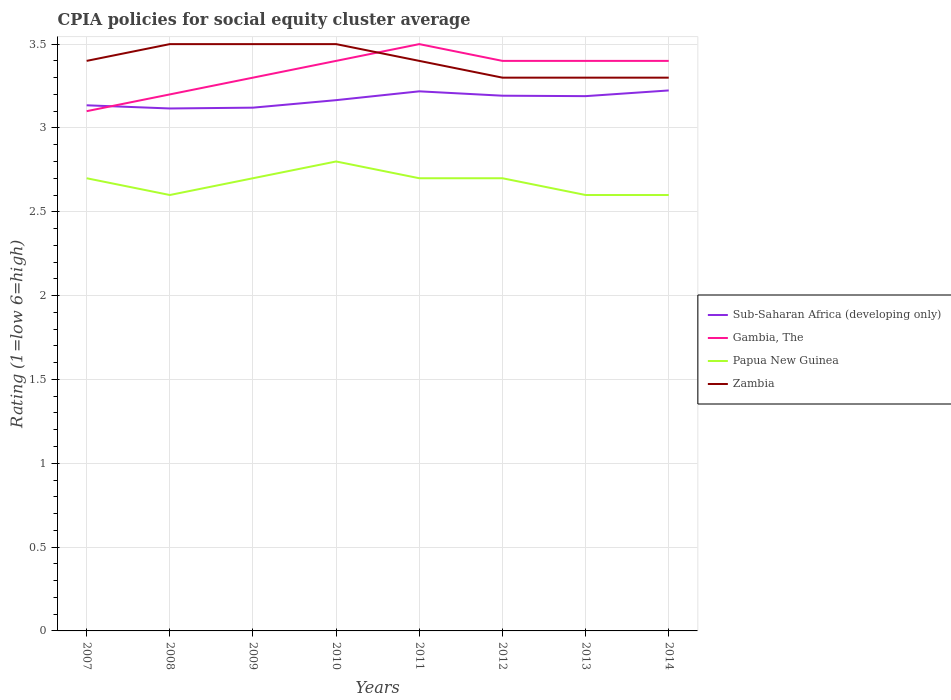Is the number of lines equal to the number of legend labels?
Make the answer very short. Yes. In which year was the CPIA rating in Zambia maximum?
Keep it short and to the point. 2012. What is the total CPIA rating in Gambia, The in the graph?
Make the answer very short. -0.2. What is the difference between the highest and the second highest CPIA rating in Sub-Saharan Africa (developing only)?
Offer a terse response. 0.11. What is the difference between the highest and the lowest CPIA rating in Gambia, The?
Provide a short and direct response. 5. How many years are there in the graph?
Make the answer very short. 8. What is the difference between two consecutive major ticks on the Y-axis?
Your answer should be very brief. 0.5. Are the values on the major ticks of Y-axis written in scientific E-notation?
Offer a terse response. No. Does the graph contain any zero values?
Provide a short and direct response. No. How many legend labels are there?
Your answer should be very brief. 4. What is the title of the graph?
Your response must be concise. CPIA policies for social equity cluster average. Does "Dominica" appear as one of the legend labels in the graph?
Give a very brief answer. No. What is the label or title of the Y-axis?
Make the answer very short. Rating (1=low 6=high). What is the Rating (1=low 6=high) in Sub-Saharan Africa (developing only) in 2007?
Your answer should be compact. 3.14. What is the Rating (1=low 6=high) in Zambia in 2007?
Offer a terse response. 3.4. What is the Rating (1=low 6=high) of Sub-Saharan Africa (developing only) in 2008?
Offer a very short reply. 3.12. What is the Rating (1=low 6=high) in Gambia, The in 2008?
Make the answer very short. 3.2. What is the Rating (1=low 6=high) of Sub-Saharan Africa (developing only) in 2009?
Give a very brief answer. 3.12. What is the Rating (1=low 6=high) of Gambia, The in 2009?
Provide a short and direct response. 3.3. What is the Rating (1=low 6=high) of Zambia in 2009?
Ensure brevity in your answer.  3.5. What is the Rating (1=low 6=high) of Sub-Saharan Africa (developing only) in 2010?
Ensure brevity in your answer.  3.17. What is the Rating (1=low 6=high) in Gambia, The in 2010?
Give a very brief answer. 3.4. What is the Rating (1=low 6=high) of Papua New Guinea in 2010?
Keep it short and to the point. 2.8. What is the Rating (1=low 6=high) of Sub-Saharan Africa (developing only) in 2011?
Ensure brevity in your answer.  3.22. What is the Rating (1=low 6=high) of Gambia, The in 2011?
Make the answer very short. 3.5. What is the Rating (1=low 6=high) in Zambia in 2011?
Your answer should be compact. 3.4. What is the Rating (1=low 6=high) of Sub-Saharan Africa (developing only) in 2012?
Keep it short and to the point. 3.19. What is the Rating (1=low 6=high) of Gambia, The in 2012?
Your response must be concise. 3.4. What is the Rating (1=low 6=high) in Papua New Guinea in 2012?
Ensure brevity in your answer.  2.7. What is the Rating (1=low 6=high) of Sub-Saharan Africa (developing only) in 2013?
Offer a very short reply. 3.19. What is the Rating (1=low 6=high) in Zambia in 2013?
Offer a terse response. 3.3. What is the Rating (1=low 6=high) in Sub-Saharan Africa (developing only) in 2014?
Provide a succinct answer. 3.22. What is the Rating (1=low 6=high) in Papua New Guinea in 2014?
Offer a terse response. 2.6. Across all years, what is the maximum Rating (1=low 6=high) of Sub-Saharan Africa (developing only)?
Ensure brevity in your answer.  3.22. Across all years, what is the maximum Rating (1=low 6=high) of Papua New Guinea?
Give a very brief answer. 2.8. Across all years, what is the minimum Rating (1=low 6=high) in Sub-Saharan Africa (developing only)?
Give a very brief answer. 3.12. Across all years, what is the minimum Rating (1=low 6=high) of Gambia, The?
Give a very brief answer. 3.1. Across all years, what is the minimum Rating (1=low 6=high) of Zambia?
Your answer should be compact. 3.3. What is the total Rating (1=low 6=high) in Sub-Saharan Africa (developing only) in the graph?
Your answer should be compact. 25.36. What is the total Rating (1=low 6=high) in Gambia, The in the graph?
Make the answer very short. 26.7. What is the total Rating (1=low 6=high) of Papua New Guinea in the graph?
Offer a very short reply. 21.4. What is the total Rating (1=low 6=high) of Zambia in the graph?
Your answer should be very brief. 27.2. What is the difference between the Rating (1=low 6=high) of Sub-Saharan Africa (developing only) in 2007 and that in 2008?
Provide a succinct answer. 0.02. What is the difference between the Rating (1=low 6=high) of Gambia, The in 2007 and that in 2008?
Ensure brevity in your answer.  -0.1. What is the difference between the Rating (1=low 6=high) in Zambia in 2007 and that in 2008?
Provide a short and direct response. -0.1. What is the difference between the Rating (1=low 6=high) of Sub-Saharan Africa (developing only) in 2007 and that in 2009?
Your answer should be compact. 0.01. What is the difference between the Rating (1=low 6=high) of Sub-Saharan Africa (developing only) in 2007 and that in 2010?
Provide a short and direct response. -0.03. What is the difference between the Rating (1=low 6=high) in Papua New Guinea in 2007 and that in 2010?
Give a very brief answer. -0.1. What is the difference between the Rating (1=low 6=high) in Sub-Saharan Africa (developing only) in 2007 and that in 2011?
Offer a terse response. -0.08. What is the difference between the Rating (1=low 6=high) of Zambia in 2007 and that in 2011?
Your answer should be very brief. 0. What is the difference between the Rating (1=low 6=high) in Sub-Saharan Africa (developing only) in 2007 and that in 2012?
Ensure brevity in your answer.  -0.06. What is the difference between the Rating (1=low 6=high) in Zambia in 2007 and that in 2012?
Make the answer very short. 0.1. What is the difference between the Rating (1=low 6=high) of Sub-Saharan Africa (developing only) in 2007 and that in 2013?
Provide a succinct answer. -0.05. What is the difference between the Rating (1=low 6=high) of Gambia, The in 2007 and that in 2013?
Offer a very short reply. -0.3. What is the difference between the Rating (1=low 6=high) of Papua New Guinea in 2007 and that in 2013?
Provide a succinct answer. 0.1. What is the difference between the Rating (1=low 6=high) of Sub-Saharan Africa (developing only) in 2007 and that in 2014?
Your answer should be compact. -0.09. What is the difference between the Rating (1=low 6=high) in Sub-Saharan Africa (developing only) in 2008 and that in 2009?
Make the answer very short. -0. What is the difference between the Rating (1=low 6=high) in Papua New Guinea in 2008 and that in 2009?
Give a very brief answer. -0.1. What is the difference between the Rating (1=low 6=high) of Sub-Saharan Africa (developing only) in 2008 and that in 2010?
Provide a short and direct response. -0.05. What is the difference between the Rating (1=low 6=high) of Zambia in 2008 and that in 2010?
Your answer should be compact. 0. What is the difference between the Rating (1=low 6=high) in Sub-Saharan Africa (developing only) in 2008 and that in 2011?
Make the answer very short. -0.1. What is the difference between the Rating (1=low 6=high) of Papua New Guinea in 2008 and that in 2011?
Offer a very short reply. -0.1. What is the difference between the Rating (1=low 6=high) of Sub-Saharan Africa (developing only) in 2008 and that in 2012?
Offer a very short reply. -0.08. What is the difference between the Rating (1=low 6=high) in Papua New Guinea in 2008 and that in 2012?
Your answer should be very brief. -0.1. What is the difference between the Rating (1=low 6=high) in Sub-Saharan Africa (developing only) in 2008 and that in 2013?
Offer a terse response. -0.07. What is the difference between the Rating (1=low 6=high) in Papua New Guinea in 2008 and that in 2013?
Offer a very short reply. 0. What is the difference between the Rating (1=low 6=high) in Zambia in 2008 and that in 2013?
Make the answer very short. 0.2. What is the difference between the Rating (1=low 6=high) in Sub-Saharan Africa (developing only) in 2008 and that in 2014?
Ensure brevity in your answer.  -0.11. What is the difference between the Rating (1=low 6=high) in Gambia, The in 2008 and that in 2014?
Offer a very short reply. -0.2. What is the difference between the Rating (1=low 6=high) of Zambia in 2008 and that in 2014?
Your answer should be compact. 0.2. What is the difference between the Rating (1=low 6=high) of Sub-Saharan Africa (developing only) in 2009 and that in 2010?
Keep it short and to the point. -0.04. What is the difference between the Rating (1=low 6=high) of Gambia, The in 2009 and that in 2010?
Offer a terse response. -0.1. What is the difference between the Rating (1=low 6=high) in Papua New Guinea in 2009 and that in 2010?
Make the answer very short. -0.1. What is the difference between the Rating (1=low 6=high) in Sub-Saharan Africa (developing only) in 2009 and that in 2011?
Offer a terse response. -0.1. What is the difference between the Rating (1=low 6=high) in Papua New Guinea in 2009 and that in 2011?
Offer a very short reply. 0. What is the difference between the Rating (1=low 6=high) in Zambia in 2009 and that in 2011?
Offer a terse response. 0.1. What is the difference between the Rating (1=low 6=high) of Sub-Saharan Africa (developing only) in 2009 and that in 2012?
Give a very brief answer. -0.07. What is the difference between the Rating (1=low 6=high) of Sub-Saharan Africa (developing only) in 2009 and that in 2013?
Your answer should be very brief. -0.07. What is the difference between the Rating (1=low 6=high) in Zambia in 2009 and that in 2013?
Your answer should be very brief. 0.2. What is the difference between the Rating (1=low 6=high) of Sub-Saharan Africa (developing only) in 2009 and that in 2014?
Keep it short and to the point. -0.1. What is the difference between the Rating (1=low 6=high) in Papua New Guinea in 2009 and that in 2014?
Provide a succinct answer. 0.1. What is the difference between the Rating (1=low 6=high) of Zambia in 2009 and that in 2014?
Provide a succinct answer. 0.2. What is the difference between the Rating (1=low 6=high) in Sub-Saharan Africa (developing only) in 2010 and that in 2011?
Offer a very short reply. -0.05. What is the difference between the Rating (1=low 6=high) in Gambia, The in 2010 and that in 2011?
Ensure brevity in your answer.  -0.1. What is the difference between the Rating (1=low 6=high) in Zambia in 2010 and that in 2011?
Make the answer very short. 0.1. What is the difference between the Rating (1=low 6=high) of Sub-Saharan Africa (developing only) in 2010 and that in 2012?
Provide a succinct answer. -0.03. What is the difference between the Rating (1=low 6=high) of Gambia, The in 2010 and that in 2012?
Your response must be concise. 0. What is the difference between the Rating (1=low 6=high) of Papua New Guinea in 2010 and that in 2012?
Ensure brevity in your answer.  0.1. What is the difference between the Rating (1=low 6=high) in Zambia in 2010 and that in 2012?
Provide a short and direct response. 0.2. What is the difference between the Rating (1=low 6=high) of Sub-Saharan Africa (developing only) in 2010 and that in 2013?
Give a very brief answer. -0.02. What is the difference between the Rating (1=low 6=high) of Gambia, The in 2010 and that in 2013?
Your response must be concise. 0. What is the difference between the Rating (1=low 6=high) of Sub-Saharan Africa (developing only) in 2010 and that in 2014?
Provide a succinct answer. -0.06. What is the difference between the Rating (1=low 6=high) in Gambia, The in 2010 and that in 2014?
Make the answer very short. 0. What is the difference between the Rating (1=low 6=high) of Papua New Guinea in 2010 and that in 2014?
Your answer should be very brief. 0.2. What is the difference between the Rating (1=low 6=high) of Sub-Saharan Africa (developing only) in 2011 and that in 2012?
Give a very brief answer. 0.03. What is the difference between the Rating (1=low 6=high) of Gambia, The in 2011 and that in 2012?
Your answer should be very brief. 0.1. What is the difference between the Rating (1=low 6=high) in Zambia in 2011 and that in 2012?
Provide a short and direct response. 0.1. What is the difference between the Rating (1=low 6=high) in Sub-Saharan Africa (developing only) in 2011 and that in 2013?
Give a very brief answer. 0.03. What is the difference between the Rating (1=low 6=high) in Papua New Guinea in 2011 and that in 2013?
Provide a short and direct response. 0.1. What is the difference between the Rating (1=low 6=high) of Zambia in 2011 and that in 2013?
Offer a very short reply. 0.1. What is the difference between the Rating (1=low 6=high) of Sub-Saharan Africa (developing only) in 2011 and that in 2014?
Your answer should be very brief. -0.01. What is the difference between the Rating (1=low 6=high) of Papua New Guinea in 2011 and that in 2014?
Your response must be concise. 0.1. What is the difference between the Rating (1=low 6=high) of Zambia in 2011 and that in 2014?
Offer a very short reply. 0.1. What is the difference between the Rating (1=low 6=high) in Sub-Saharan Africa (developing only) in 2012 and that in 2013?
Provide a short and direct response. 0. What is the difference between the Rating (1=low 6=high) of Gambia, The in 2012 and that in 2013?
Offer a very short reply. 0. What is the difference between the Rating (1=low 6=high) of Papua New Guinea in 2012 and that in 2013?
Provide a succinct answer. 0.1. What is the difference between the Rating (1=low 6=high) in Zambia in 2012 and that in 2013?
Make the answer very short. 0. What is the difference between the Rating (1=low 6=high) of Sub-Saharan Africa (developing only) in 2012 and that in 2014?
Keep it short and to the point. -0.03. What is the difference between the Rating (1=low 6=high) in Gambia, The in 2012 and that in 2014?
Keep it short and to the point. 0. What is the difference between the Rating (1=low 6=high) in Sub-Saharan Africa (developing only) in 2013 and that in 2014?
Give a very brief answer. -0.03. What is the difference between the Rating (1=low 6=high) in Gambia, The in 2013 and that in 2014?
Your answer should be very brief. 0. What is the difference between the Rating (1=low 6=high) in Sub-Saharan Africa (developing only) in 2007 and the Rating (1=low 6=high) in Gambia, The in 2008?
Offer a very short reply. -0.06. What is the difference between the Rating (1=low 6=high) of Sub-Saharan Africa (developing only) in 2007 and the Rating (1=low 6=high) of Papua New Guinea in 2008?
Give a very brief answer. 0.54. What is the difference between the Rating (1=low 6=high) of Sub-Saharan Africa (developing only) in 2007 and the Rating (1=low 6=high) of Zambia in 2008?
Offer a very short reply. -0.36. What is the difference between the Rating (1=low 6=high) in Gambia, The in 2007 and the Rating (1=low 6=high) in Papua New Guinea in 2008?
Provide a short and direct response. 0.5. What is the difference between the Rating (1=low 6=high) in Gambia, The in 2007 and the Rating (1=low 6=high) in Zambia in 2008?
Your answer should be very brief. -0.4. What is the difference between the Rating (1=low 6=high) in Papua New Guinea in 2007 and the Rating (1=low 6=high) in Zambia in 2008?
Provide a short and direct response. -0.8. What is the difference between the Rating (1=low 6=high) in Sub-Saharan Africa (developing only) in 2007 and the Rating (1=low 6=high) in Gambia, The in 2009?
Ensure brevity in your answer.  -0.16. What is the difference between the Rating (1=low 6=high) of Sub-Saharan Africa (developing only) in 2007 and the Rating (1=low 6=high) of Papua New Guinea in 2009?
Your response must be concise. 0.44. What is the difference between the Rating (1=low 6=high) of Sub-Saharan Africa (developing only) in 2007 and the Rating (1=low 6=high) of Zambia in 2009?
Your response must be concise. -0.36. What is the difference between the Rating (1=low 6=high) in Sub-Saharan Africa (developing only) in 2007 and the Rating (1=low 6=high) in Gambia, The in 2010?
Your answer should be very brief. -0.26. What is the difference between the Rating (1=low 6=high) in Sub-Saharan Africa (developing only) in 2007 and the Rating (1=low 6=high) in Papua New Guinea in 2010?
Offer a very short reply. 0.34. What is the difference between the Rating (1=low 6=high) of Sub-Saharan Africa (developing only) in 2007 and the Rating (1=low 6=high) of Zambia in 2010?
Provide a short and direct response. -0.36. What is the difference between the Rating (1=low 6=high) in Gambia, The in 2007 and the Rating (1=low 6=high) in Papua New Guinea in 2010?
Your answer should be compact. 0.3. What is the difference between the Rating (1=low 6=high) in Gambia, The in 2007 and the Rating (1=low 6=high) in Zambia in 2010?
Make the answer very short. -0.4. What is the difference between the Rating (1=low 6=high) in Sub-Saharan Africa (developing only) in 2007 and the Rating (1=low 6=high) in Gambia, The in 2011?
Your response must be concise. -0.36. What is the difference between the Rating (1=low 6=high) in Sub-Saharan Africa (developing only) in 2007 and the Rating (1=low 6=high) in Papua New Guinea in 2011?
Make the answer very short. 0.44. What is the difference between the Rating (1=low 6=high) in Sub-Saharan Africa (developing only) in 2007 and the Rating (1=low 6=high) in Zambia in 2011?
Give a very brief answer. -0.26. What is the difference between the Rating (1=low 6=high) in Gambia, The in 2007 and the Rating (1=low 6=high) in Zambia in 2011?
Offer a terse response. -0.3. What is the difference between the Rating (1=low 6=high) in Papua New Guinea in 2007 and the Rating (1=low 6=high) in Zambia in 2011?
Your answer should be very brief. -0.7. What is the difference between the Rating (1=low 6=high) in Sub-Saharan Africa (developing only) in 2007 and the Rating (1=low 6=high) in Gambia, The in 2012?
Make the answer very short. -0.26. What is the difference between the Rating (1=low 6=high) in Sub-Saharan Africa (developing only) in 2007 and the Rating (1=low 6=high) in Papua New Guinea in 2012?
Make the answer very short. 0.44. What is the difference between the Rating (1=low 6=high) in Sub-Saharan Africa (developing only) in 2007 and the Rating (1=low 6=high) in Zambia in 2012?
Your answer should be very brief. -0.16. What is the difference between the Rating (1=low 6=high) in Sub-Saharan Africa (developing only) in 2007 and the Rating (1=low 6=high) in Gambia, The in 2013?
Provide a succinct answer. -0.26. What is the difference between the Rating (1=low 6=high) of Sub-Saharan Africa (developing only) in 2007 and the Rating (1=low 6=high) of Papua New Guinea in 2013?
Offer a very short reply. 0.54. What is the difference between the Rating (1=low 6=high) in Sub-Saharan Africa (developing only) in 2007 and the Rating (1=low 6=high) in Zambia in 2013?
Keep it short and to the point. -0.16. What is the difference between the Rating (1=low 6=high) of Gambia, The in 2007 and the Rating (1=low 6=high) of Zambia in 2013?
Your answer should be compact. -0.2. What is the difference between the Rating (1=low 6=high) in Papua New Guinea in 2007 and the Rating (1=low 6=high) in Zambia in 2013?
Your answer should be compact. -0.6. What is the difference between the Rating (1=low 6=high) of Sub-Saharan Africa (developing only) in 2007 and the Rating (1=low 6=high) of Gambia, The in 2014?
Keep it short and to the point. -0.26. What is the difference between the Rating (1=low 6=high) of Sub-Saharan Africa (developing only) in 2007 and the Rating (1=low 6=high) of Papua New Guinea in 2014?
Make the answer very short. 0.54. What is the difference between the Rating (1=low 6=high) of Sub-Saharan Africa (developing only) in 2007 and the Rating (1=low 6=high) of Zambia in 2014?
Ensure brevity in your answer.  -0.16. What is the difference between the Rating (1=low 6=high) of Gambia, The in 2007 and the Rating (1=low 6=high) of Papua New Guinea in 2014?
Ensure brevity in your answer.  0.5. What is the difference between the Rating (1=low 6=high) of Sub-Saharan Africa (developing only) in 2008 and the Rating (1=low 6=high) of Gambia, The in 2009?
Your response must be concise. -0.18. What is the difference between the Rating (1=low 6=high) in Sub-Saharan Africa (developing only) in 2008 and the Rating (1=low 6=high) in Papua New Guinea in 2009?
Make the answer very short. 0.42. What is the difference between the Rating (1=low 6=high) in Sub-Saharan Africa (developing only) in 2008 and the Rating (1=low 6=high) in Zambia in 2009?
Keep it short and to the point. -0.38. What is the difference between the Rating (1=low 6=high) of Sub-Saharan Africa (developing only) in 2008 and the Rating (1=low 6=high) of Gambia, The in 2010?
Provide a short and direct response. -0.28. What is the difference between the Rating (1=low 6=high) of Sub-Saharan Africa (developing only) in 2008 and the Rating (1=low 6=high) of Papua New Guinea in 2010?
Keep it short and to the point. 0.32. What is the difference between the Rating (1=low 6=high) of Sub-Saharan Africa (developing only) in 2008 and the Rating (1=low 6=high) of Zambia in 2010?
Provide a succinct answer. -0.38. What is the difference between the Rating (1=low 6=high) of Papua New Guinea in 2008 and the Rating (1=low 6=high) of Zambia in 2010?
Ensure brevity in your answer.  -0.9. What is the difference between the Rating (1=low 6=high) of Sub-Saharan Africa (developing only) in 2008 and the Rating (1=low 6=high) of Gambia, The in 2011?
Your answer should be compact. -0.38. What is the difference between the Rating (1=low 6=high) in Sub-Saharan Africa (developing only) in 2008 and the Rating (1=low 6=high) in Papua New Guinea in 2011?
Provide a short and direct response. 0.42. What is the difference between the Rating (1=low 6=high) in Sub-Saharan Africa (developing only) in 2008 and the Rating (1=low 6=high) in Zambia in 2011?
Your answer should be very brief. -0.28. What is the difference between the Rating (1=low 6=high) of Sub-Saharan Africa (developing only) in 2008 and the Rating (1=low 6=high) of Gambia, The in 2012?
Keep it short and to the point. -0.28. What is the difference between the Rating (1=low 6=high) of Sub-Saharan Africa (developing only) in 2008 and the Rating (1=low 6=high) of Papua New Guinea in 2012?
Give a very brief answer. 0.42. What is the difference between the Rating (1=low 6=high) of Sub-Saharan Africa (developing only) in 2008 and the Rating (1=low 6=high) of Zambia in 2012?
Make the answer very short. -0.18. What is the difference between the Rating (1=low 6=high) of Sub-Saharan Africa (developing only) in 2008 and the Rating (1=low 6=high) of Gambia, The in 2013?
Ensure brevity in your answer.  -0.28. What is the difference between the Rating (1=low 6=high) of Sub-Saharan Africa (developing only) in 2008 and the Rating (1=low 6=high) of Papua New Guinea in 2013?
Provide a short and direct response. 0.52. What is the difference between the Rating (1=low 6=high) of Sub-Saharan Africa (developing only) in 2008 and the Rating (1=low 6=high) of Zambia in 2013?
Provide a succinct answer. -0.18. What is the difference between the Rating (1=low 6=high) in Gambia, The in 2008 and the Rating (1=low 6=high) in Zambia in 2013?
Offer a very short reply. -0.1. What is the difference between the Rating (1=low 6=high) in Sub-Saharan Africa (developing only) in 2008 and the Rating (1=low 6=high) in Gambia, The in 2014?
Offer a very short reply. -0.28. What is the difference between the Rating (1=low 6=high) in Sub-Saharan Africa (developing only) in 2008 and the Rating (1=low 6=high) in Papua New Guinea in 2014?
Provide a short and direct response. 0.52. What is the difference between the Rating (1=low 6=high) in Sub-Saharan Africa (developing only) in 2008 and the Rating (1=low 6=high) in Zambia in 2014?
Provide a short and direct response. -0.18. What is the difference between the Rating (1=low 6=high) of Gambia, The in 2008 and the Rating (1=low 6=high) of Papua New Guinea in 2014?
Provide a short and direct response. 0.6. What is the difference between the Rating (1=low 6=high) in Papua New Guinea in 2008 and the Rating (1=low 6=high) in Zambia in 2014?
Provide a succinct answer. -0.7. What is the difference between the Rating (1=low 6=high) in Sub-Saharan Africa (developing only) in 2009 and the Rating (1=low 6=high) in Gambia, The in 2010?
Ensure brevity in your answer.  -0.28. What is the difference between the Rating (1=low 6=high) in Sub-Saharan Africa (developing only) in 2009 and the Rating (1=low 6=high) in Papua New Guinea in 2010?
Keep it short and to the point. 0.32. What is the difference between the Rating (1=low 6=high) in Sub-Saharan Africa (developing only) in 2009 and the Rating (1=low 6=high) in Zambia in 2010?
Your answer should be very brief. -0.38. What is the difference between the Rating (1=low 6=high) in Gambia, The in 2009 and the Rating (1=low 6=high) in Papua New Guinea in 2010?
Ensure brevity in your answer.  0.5. What is the difference between the Rating (1=low 6=high) of Papua New Guinea in 2009 and the Rating (1=low 6=high) of Zambia in 2010?
Keep it short and to the point. -0.8. What is the difference between the Rating (1=low 6=high) in Sub-Saharan Africa (developing only) in 2009 and the Rating (1=low 6=high) in Gambia, The in 2011?
Ensure brevity in your answer.  -0.38. What is the difference between the Rating (1=low 6=high) of Sub-Saharan Africa (developing only) in 2009 and the Rating (1=low 6=high) of Papua New Guinea in 2011?
Provide a succinct answer. 0.42. What is the difference between the Rating (1=low 6=high) of Sub-Saharan Africa (developing only) in 2009 and the Rating (1=low 6=high) of Zambia in 2011?
Make the answer very short. -0.28. What is the difference between the Rating (1=low 6=high) in Papua New Guinea in 2009 and the Rating (1=low 6=high) in Zambia in 2011?
Keep it short and to the point. -0.7. What is the difference between the Rating (1=low 6=high) of Sub-Saharan Africa (developing only) in 2009 and the Rating (1=low 6=high) of Gambia, The in 2012?
Ensure brevity in your answer.  -0.28. What is the difference between the Rating (1=low 6=high) in Sub-Saharan Africa (developing only) in 2009 and the Rating (1=low 6=high) in Papua New Guinea in 2012?
Your answer should be very brief. 0.42. What is the difference between the Rating (1=low 6=high) of Sub-Saharan Africa (developing only) in 2009 and the Rating (1=low 6=high) of Zambia in 2012?
Ensure brevity in your answer.  -0.18. What is the difference between the Rating (1=low 6=high) in Gambia, The in 2009 and the Rating (1=low 6=high) in Papua New Guinea in 2012?
Keep it short and to the point. 0.6. What is the difference between the Rating (1=low 6=high) in Papua New Guinea in 2009 and the Rating (1=low 6=high) in Zambia in 2012?
Give a very brief answer. -0.6. What is the difference between the Rating (1=low 6=high) in Sub-Saharan Africa (developing only) in 2009 and the Rating (1=low 6=high) in Gambia, The in 2013?
Provide a succinct answer. -0.28. What is the difference between the Rating (1=low 6=high) of Sub-Saharan Africa (developing only) in 2009 and the Rating (1=low 6=high) of Papua New Guinea in 2013?
Ensure brevity in your answer.  0.52. What is the difference between the Rating (1=low 6=high) in Sub-Saharan Africa (developing only) in 2009 and the Rating (1=low 6=high) in Zambia in 2013?
Offer a very short reply. -0.18. What is the difference between the Rating (1=low 6=high) of Sub-Saharan Africa (developing only) in 2009 and the Rating (1=low 6=high) of Gambia, The in 2014?
Your response must be concise. -0.28. What is the difference between the Rating (1=low 6=high) in Sub-Saharan Africa (developing only) in 2009 and the Rating (1=low 6=high) in Papua New Guinea in 2014?
Give a very brief answer. 0.52. What is the difference between the Rating (1=low 6=high) in Sub-Saharan Africa (developing only) in 2009 and the Rating (1=low 6=high) in Zambia in 2014?
Your answer should be compact. -0.18. What is the difference between the Rating (1=low 6=high) of Sub-Saharan Africa (developing only) in 2010 and the Rating (1=low 6=high) of Gambia, The in 2011?
Offer a terse response. -0.33. What is the difference between the Rating (1=low 6=high) in Sub-Saharan Africa (developing only) in 2010 and the Rating (1=low 6=high) in Papua New Guinea in 2011?
Your response must be concise. 0.47. What is the difference between the Rating (1=low 6=high) in Sub-Saharan Africa (developing only) in 2010 and the Rating (1=low 6=high) in Zambia in 2011?
Provide a short and direct response. -0.23. What is the difference between the Rating (1=low 6=high) of Gambia, The in 2010 and the Rating (1=low 6=high) of Papua New Guinea in 2011?
Ensure brevity in your answer.  0.7. What is the difference between the Rating (1=low 6=high) of Gambia, The in 2010 and the Rating (1=low 6=high) of Zambia in 2011?
Make the answer very short. 0. What is the difference between the Rating (1=low 6=high) of Sub-Saharan Africa (developing only) in 2010 and the Rating (1=low 6=high) of Gambia, The in 2012?
Your answer should be compact. -0.23. What is the difference between the Rating (1=low 6=high) of Sub-Saharan Africa (developing only) in 2010 and the Rating (1=low 6=high) of Papua New Guinea in 2012?
Ensure brevity in your answer.  0.47. What is the difference between the Rating (1=low 6=high) of Sub-Saharan Africa (developing only) in 2010 and the Rating (1=low 6=high) of Zambia in 2012?
Provide a succinct answer. -0.13. What is the difference between the Rating (1=low 6=high) of Sub-Saharan Africa (developing only) in 2010 and the Rating (1=low 6=high) of Gambia, The in 2013?
Provide a short and direct response. -0.23. What is the difference between the Rating (1=low 6=high) of Sub-Saharan Africa (developing only) in 2010 and the Rating (1=low 6=high) of Papua New Guinea in 2013?
Provide a short and direct response. 0.57. What is the difference between the Rating (1=low 6=high) of Sub-Saharan Africa (developing only) in 2010 and the Rating (1=low 6=high) of Zambia in 2013?
Your answer should be compact. -0.13. What is the difference between the Rating (1=low 6=high) in Gambia, The in 2010 and the Rating (1=low 6=high) in Papua New Guinea in 2013?
Your answer should be very brief. 0.8. What is the difference between the Rating (1=low 6=high) in Sub-Saharan Africa (developing only) in 2010 and the Rating (1=low 6=high) in Gambia, The in 2014?
Keep it short and to the point. -0.23. What is the difference between the Rating (1=low 6=high) of Sub-Saharan Africa (developing only) in 2010 and the Rating (1=low 6=high) of Papua New Guinea in 2014?
Provide a succinct answer. 0.57. What is the difference between the Rating (1=low 6=high) of Sub-Saharan Africa (developing only) in 2010 and the Rating (1=low 6=high) of Zambia in 2014?
Keep it short and to the point. -0.13. What is the difference between the Rating (1=low 6=high) in Papua New Guinea in 2010 and the Rating (1=low 6=high) in Zambia in 2014?
Offer a very short reply. -0.5. What is the difference between the Rating (1=low 6=high) of Sub-Saharan Africa (developing only) in 2011 and the Rating (1=low 6=high) of Gambia, The in 2012?
Keep it short and to the point. -0.18. What is the difference between the Rating (1=low 6=high) of Sub-Saharan Africa (developing only) in 2011 and the Rating (1=low 6=high) of Papua New Guinea in 2012?
Keep it short and to the point. 0.52. What is the difference between the Rating (1=low 6=high) in Sub-Saharan Africa (developing only) in 2011 and the Rating (1=low 6=high) in Zambia in 2012?
Your response must be concise. -0.08. What is the difference between the Rating (1=low 6=high) of Gambia, The in 2011 and the Rating (1=low 6=high) of Papua New Guinea in 2012?
Provide a succinct answer. 0.8. What is the difference between the Rating (1=low 6=high) of Sub-Saharan Africa (developing only) in 2011 and the Rating (1=low 6=high) of Gambia, The in 2013?
Give a very brief answer. -0.18. What is the difference between the Rating (1=low 6=high) of Sub-Saharan Africa (developing only) in 2011 and the Rating (1=low 6=high) of Papua New Guinea in 2013?
Your answer should be compact. 0.62. What is the difference between the Rating (1=low 6=high) of Sub-Saharan Africa (developing only) in 2011 and the Rating (1=low 6=high) of Zambia in 2013?
Keep it short and to the point. -0.08. What is the difference between the Rating (1=low 6=high) of Sub-Saharan Africa (developing only) in 2011 and the Rating (1=low 6=high) of Gambia, The in 2014?
Offer a very short reply. -0.18. What is the difference between the Rating (1=low 6=high) in Sub-Saharan Africa (developing only) in 2011 and the Rating (1=low 6=high) in Papua New Guinea in 2014?
Provide a short and direct response. 0.62. What is the difference between the Rating (1=low 6=high) in Sub-Saharan Africa (developing only) in 2011 and the Rating (1=low 6=high) in Zambia in 2014?
Make the answer very short. -0.08. What is the difference between the Rating (1=low 6=high) in Gambia, The in 2011 and the Rating (1=low 6=high) in Zambia in 2014?
Offer a terse response. 0.2. What is the difference between the Rating (1=low 6=high) in Sub-Saharan Africa (developing only) in 2012 and the Rating (1=low 6=high) in Gambia, The in 2013?
Offer a terse response. -0.21. What is the difference between the Rating (1=low 6=high) in Sub-Saharan Africa (developing only) in 2012 and the Rating (1=low 6=high) in Papua New Guinea in 2013?
Ensure brevity in your answer.  0.59. What is the difference between the Rating (1=low 6=high) in Sub-Saharan Africa (developing only) in 2012 and the Rating (1=low 6=high) in Zambia in 2013?
Your answer should be very brief. -0.11. What is the difference between the Rating (1=low 6=high) of Gambia, The in 2012 and the Rating (1=low 6=high) of Papua New Guinea in 2013?
Keep it short and to the point. 0.8. What is the difference between the Rating (1=low 6=high) in Gambia, The in 2012 and the Rating (1=low 6=high) in Zambia in 2013?
Provide a short and direct response. 0.1. What is the difference between the Rating (1=low 6=high) of Sub-Saharan Africa (developing only) in 2012 and the Rating (1=low 6=high) of Gambia, The in 2014?
Your answer should be compact. -0.21. What is the difference between the Rating (1=low 6=high) in Sub-Saharan Africa (developing only) in 2012 and the Rating (1=low 6=high) in Papua New Guinea in 2014?
Make the answer very short. 0.59. What is the difference between the Rating (1=low 6=high) of Sub-Saharan Africa (developing only) in 2012 and the Rating (1=low 6=high) of Zambia in 2014?
Make the answer very short. -0.11. What is the difference between the Rating (1=low 6=high) of Gambia, The in 2012 and the Rating (1=low 6=high) of Papua New Guinea in 2014?
Your answer should be very brief. 0.8. What is the difference between the Rating (1=low 6=high) in Gambia, The in 2012 and the Rating (1=low 6=high) in Zambia in 2014?
Offer a very short reply. 0.1. What is the difference between the Rating (1=low 6=high) in Sub-Saharan Africa (developing only) in 2013 and the Rating (1=low 6=high) in Gambia, The in 2014?
Make the answer very short. -0.21. What is the difference between the Rating (1=low 6=high) in Sub-Saharan Africa (developing only) in 2013 and the Rating (1=low 6=high) in Papua New Guinea in 2014?
Make the answer very short. 0.59. What is the difference between the Rating (1=low 6=high) of Sub-Saharan Africa (developing only) in 2013 and the Rating (1=low 6=high) of Zambia in 2014?
Give a very brief answer. -0.11. What is the difference between the Rating (1=low 6=high) in Gambia, The in 2013 and the Rating (1=low 6=high) in Zambia in 2014?
Your answer should be very brief. 0.1. What is the difference between the Rating (1=low 6=high) in Papua New Guinea in 2013 and the Rating (1=low 6=high) in Zambia in 2014?
Provide a succinct answer. -0.7. What is the average Rating (1=low 6=high) of Sub-Saharan Africa (developing only) per year?
Ensure brevity in your answer.  3.17. What is the average Rating (1=low 6=high) in Gambia, The per year?
Your answer should be very brief. 3.34. What is the average Rating (1=low 6=high) of Papua New Guinea per year?
Keep it short and to the point. 2.67. What is the average Rating (1=low 6=high) of Zambia per year?
Provide a short and direct response. 3.4. In the year 2007, what is the difference between the Rating (1=low 6=high) of Sub-Saharan Africa (developing only) and Rating (1=low 6=high) of Gambia, The?
Keep it short and to the point. 0.04. In the year 2007, what is the difference between the Rating (1=low 6=high) of Sub-Saharan Africa (developing only) and Rating (1=low 6=high) of Papua New Guinea?
Your answer should be very brief. 0.44. In the year 2007, what is the difference between the Rating (1=low 6=high) of Sub-Saharan Africa (developing only) and Rating (1=low 6=high) of Zambia?
Provide a short and direct response. -0.26. In the year 2008, what is the difference between the Rating (1=low 6=high) of Sub-Saharan Africa (developing only) and Rating (1=low 6=high) of Gambia, The?
Give a very brief answer. -0.08. In the year 2008, what is the difference between the Rating (1=low 6=high) of Sub-Saharan Africa (developing only) and Rating (1=low 6=high) of Papua New Guinea?
Keep it short and to the point. 0.52. In the year 2008, what is the difference between the Rating (1=low 6=high) in Sub-Saharan Africa (developing only) and Rating (1=low 6=high) in Zambia?
Your answer should be compact. -0.38. In the year 2009, what is the difference between the Rating (1=low 6=high) in Sub-Saharan Africa (developing only) and Rating (1=low 6=high) in Gambia, The?
Offer a very short reply. -0.18. In the year 2009, what is the difference between the Rating (1=low 6=high) in Sub-Saharan Africa (developing only) and Rating (1=low 6=high) in Papua New Guinea?
Your response must be concise. 0.42. In the year 2009, what is the difference between the Rating (1=low 6=high) in Sub-Saharan Africa (developing only) and Rating (1=low 6=high) in Zambia?
Your answer should be very brief. -0.38. In the year 2009, what is the difference between the Rating (1=low 6=high) in Papua New Guinea and Rating (1=low 6=high) in Zambia?
Your response must be concise. -0.8. In the year 2010, what is the difference between the Rating (1=low 6=high) of Sub-Saharan Africa (developing only) and Rating (1=low 6=high) of Gambia, The?
Make the answer very short. -0.23. In the year 2010, what is the difference between the Rating (1=low 6=high) of Sub-Saharan Africa (developing only) and Rating (1=low 6=high) of Papua New Guinea?
Provide a short and direct response. 0.37. In the year 2010, what is the difference between the Rating (1=low 6=high) of Sub-Saharan Africa (developing only) and Rating (1=low 6=high) of Zambia?
Your answer should be compact. -0.33. In the year 2010, what is the difference between the Rating (1=low 6=high) in Gambia, The and Rating (1=low 6=high) in Zambia?
Keep it short and to the point. -0.1. In the year 2011, what is the difference between the Rating (1=low 6=high) in Sub-Saharan Africa (developing only) and Rating (1=low 6=high) in Gambia, The?
Your answer should be very brief. -0.28. In the year 2011, what is the difference between the Rating (1=low 6=high) in Sub-Saharan Africa (developing only) and Rating (1=low 6=high) in Papua New Guinea?
Provide a succinct answer. 0.52. In the year 2011, what is the difference between the Rating (1=low 6=high) of Sub-Saharan Africa (developing only) and Rating (1=low 6=high) of Zambia?
Your answer should be very brief. -0.18. In the year 2011, what is the difference between the Rating (1=low 6=high) in Gambia, The and Rating (1=low 6=high) in Zambia?
Keep it short and to the point. 0.1. In the year 2011, what is the difference between the Rating (1=low 6=high) of Papua New Guinea and Rating (1=low 6=high) of Zambia?
Provide a short and direct response. -0.7. In the year 2012, what is the difference between the Rating (1=low 6=high) of Sub-Saharan Africa (developing only) and Rating (1=low 6=high) of Gambia, The?
Keep it short and to the point. -0.21. In the year 2012, what is the difference between the Rating (1=low 6=high) in Sub-Saharan Africa (developing only) and Rating (1=low 6=high) in Papua New Guinea?
Ensure brevity in your answer.  0.49. In the year 2012, what is the difference between the Rating (1=low 6=high) of Sub-Saharan Africa (developing only) and Rating (1=low 6=high) of Zambia?
Your answer should be compact. -0.11. In the year 2012, what is the difference between the Rating (1=low 6=high) in Gambia, The and Rating (1=low 6=high) in Papua New Guinea?
Keep it short and to the point. 0.7. In the year 2012, what is the difference between the Rating (1=low 6=high) of Gambia, The and Rating (1=low 6=high) of Zambia?
Your response must be concise. 0.1. In the year 2013, what is the difference between the Rating (1=low 6=high) in Sub-Saharan Africa (developing only) and Rating (1=low 6=high) in Gambia, The?
Ensure brevity in your answer.  -0.21. In the year 2013, what is the difference between the Rating (1=low 6=high) in Sub-Saharan Africa (developing only) and Rating (1=low 6=high) in Papua New Guinea?
Provide a short and direct response. 0.59. In the year 2013, what is the difference between the Rating (1=low 6=high) of Sub-Saharan Africa (developing only) and Rating (1=low 6=high) of Zambia?
Offer a terse response. -0.11. In the year 2014, what is the difference between the Rating (1=low 6=high) in Sub-Saharan Africa (developing only) and Rating (1=low 6=high) in Gambia, The?
Make the answer very short. -0.18. In the year 2014, what is the difference between the Rating (1=low 6=high) in Sub-Saharan Africa (developing only) and Rating (1=low 6=high) in Papua New Guinea?
Ensure brevity in your answer.  0.62. In the year 2014, what is the difference between the Rating (1=low 6=high) of Sub-Saharan Africa (developing only) and Rating (1=low 6=high) of Zambia?
Your answer should be very brief. -0.08. In the year 2014, what is the difference between the Rating (1=low 6=high) of Gambia, The and Rating (1=low 6=high) of Papua New Guinea?
Your response must be concise. 0.8. In the year 2014, what is the difference between the Rating (1=low 6=high) of Gambia, The and Rating (1=low 6=high) of Zambia?
Your answer should be very brief. 0.1. What is the ratio of the Rating (1=low 6=high) in Sub-Saharan Africa (developing only) in 2007 to that in 2008?
Offer a very short reply. 1.01. What is the ratio of the Rating (1=low 6=high) of Gambia, The in 2007 to that in 2008?
Provide a succinct answer. 0.97. What is the ratio of the Rating (1=low 6=high) of Zambia in 2007 to that in 2008?
Your answer should be very brief. 0.97. What is the ratio of the Rating (1=low 6=high) of Gambia, The in 2007 to that in 2009?
Offer a terse response. 0.94. What is the ratio of the Rating (1=low 6=high) of Zambia in 2007 to that in 2009?
Give a very brief answer. 0.97. What is the ratio of the Rating (1=low 6=high) in Sub-Saharan Africa (developing only) in 2007 to that in 2010?
Give a very brief answer. 0.99. What is the ratio of the Rating (1=low 6=high) in Gambia, The in 2007 to that in 2010?
Your answer should be very brief. 0.91. What is the ratio of the Rating (1=low 6=high) of Papua New Guinea in 2007 to that in 2010?
Make the answer very short. 0.96. What is the ratio of the Rating (1=low 6=high) of Zambia in 2007 to that in 2010?
Your answer should be very brief. 0.97. What is the ratio of the Rating (1=low 6=high) of Sub-Saharan Africa (developing only) in 2007 to that in 2011?
Offer a terse response. 0.97. What is the ratio of the Rating (1=low 6=high) of Gambia, The in 2007 to that in 2011?
Make the answer very short. 0.89. What is the ratio of the Rating (1=low 6=high) in Papua New Guinea in 2007 to that in 2011?
Your answer should be compact. 1. What is the ratio of the Rating (1=low 6=high) in Zambia in 2007 to that in 2011?
Provide a succinct answer. 1. What is the ratio of the Rating (1=low 6=high) in Sub-Saharan Africa (developing only) in 2007 to that in 2012?
Provide a short and direct response. 0.98. What is the ratio of the Rating (1=low 6=high) of Gambia, The in 2007 to that in 2012?
Provide a succinct answer. 0.91. What is the ratio of the Rating (1=low 6=high) in Papua New Guinea in 2007 to that in 2012?
Your response must be concise. 1. What is the ratio of the Rating (1=low 6=high) of Zambia in 2007 to that in 2012?
Your answer should be compact. 1.03. What is the ratio of the Rating (1=low 6=high) in Sub-Saharan Africa (developing only) in 2007 to that in 2013?
Offer a terse response. 0.98. What is the ratio of the Rating (1=low 6=high) of Gambia, The in 2007 to that in 2013?
Provide a succinct answer. 0.91. What is the ratio of the Rating (1=low 6=high) of Zambia in 2007 to that in 2013?
Give a very brief answer. 1.03. What is the ratio of the Rating (1=low 6=high) in Sub-Saharan Africa (developing only) in 2007 to that in 2014?
Provide a succinct answer. 0.97. What is the ratio of the Rating (1=low 6=high) of Gambia, The in 2007 to that in 2014?
Your answer should be compact. 0.91. What is the ratio of the Rating (1=low 6=high) of Papua New Guinea in 2007 to that in 2014?
Your answer should be compact. 1.04. What is the ratio of the Rating (1=low 6=high) in Zambia in 2007 to that in 2014?
Provide a succinct answer. 1.03. What is the ratio of the Rating (1=low 6=high) in Gambia, The in 2008 to that in 2009?
Provide a short and direct response. 0.97. What is the ratio of the Rating (1=low 6=high) in Sub-Saharan Africa (developing only) in 2008 to that in 2010?
Make the answer very short. 0.98. What is the ratio of the Rating (1=low 6=high) of Gambia, The in 2008 to that in 2010?
Your answer should be compact. 0.94. What is the ratio of the Rating (1=low 6=high) in Papua New Guinea in 2008 to that in 2010?
Your answer should be compact. 0.93. What is the ratio of the Rating (1=low 6=high) in Sub-Saharan Africa (developing only) in 2008 to that in 2011?
Ensure brevity in your answer.  0.97. What is the ratio of the Rating (1=low 6=high) of Gambia, The in 2008 to that in 2011?
Your response must be concise. 0.91. What is the ratio of the Rating (1=low 6=high) in Zambia in 2008 to that in 2011?
Make the answer very short. 1.03. What is the ratio of the Rating (1=low 6=high) in Sub-Saharan Africa (developing only) in 2008 to that in 2012?
Ensure brevity in your answer.  0.98. What is the ratio of the Rating (1=low 6=high) of Papua New Guinea in 2008 to that in 2012?
Keep it short and to the point. 0.96. What is the ratio of the Rating (1=low 6=high) in Zambia in 2008 to that in 2012?
Make the answer very short. 1.06. What is the ratio of the Rating (1=low 6=high) in Sub-Saharan Africa (developing only) in 2008 to that in 2013?
Keep it short and to the point. 0.98. What is the ratio of the Rating (1=low 6=high) in Gambia, The in 2008 to that in 2013?
Provide a short and direct response. 0.94. What is the ratio of the Rating (1=low 6=high) of Zambia in 2008 to that in 2013?
Make the answer very short. 1.06. What is the ratio of the Rating (1=low 6=high) of Sub-Saharan Africa (developing only) in 2008 to that in 2014?
Give a very brief answer. 0.97. What is the ratio of the Rating (1=low 6=high) of Zambia in 2008 to that in 2014?
Provide a succinct answer. 1.06. What is the ratio of the Rating (1=low 6=high) in Sub-Saharan Africa (developing only) in 2009 to that in 2010?
Keep it short and to the point. 0.99. What is the ratio of the Rating (1=low 6=high) of Gambia, The in 2009 to that in 2010?
Make the answer very short. 0.97. What is the ratio of the Rating (1=low 6=high) in Sub-Saharan Africa (developing only) in 2009 to that in 2011?
Your answer should be compact. 0.97. What is the ratio of the Rating (1=low 6=high) in Gambia, The in 2009 to that in 2011?
Your answer should be very brief. 0.94. What is the ratio of the Rating (1=low 6=high) in Zambia in 2009 to that in 2011?
Offer a terse response. 1.03. What is the ratio of the Rating (1=low 6=high) of Sub-Saharan Africa (developing only) in 2009 to that in 2012?
Provide a succinct answer. 0.98. What is the ratio of the Rating (1=low 6=high) of Gambia, The in 2009 to that in 2012?
Your answer should be very brief. 0.97. What is the ratio of the Rating (1=low 6=high) of Papua New Guinea in 2009 to that in 2012?
Offer a very short reply. 1. What is the ratio of the Rating (1=low 6=high) of Zambia in 2009 to that in 2012?
Your answer should be very brief. 1.06. What is the ratio of the Rating (1=low 6=high) in Sub-Saharan Africa (developing only) in 2009 to that in 2013?
Offer a very short reply. 0.98. What is the ratio of the Rating (1=low 6=high) in Gambia, The in 2009 to that in 2013?
Your answer should be compact. 0.97. What is the ratio of the Rating (1=low 6=high) of Zambia in 2009 to that in 2013?
Keep it short and to the point. 1.06. What is the ratio of the Rating (1=low 6=high) in Sub-Saharan Africa (developing only) in 2009 to that in 2014?
Make the answer very short. 0.97. What is the ratio of the Rating (1=low 6=high) in Gambia, The in 2009 to that in 2014?
Your answer should be very brief. 0.97. What is the ratio of the Rating (1=low 6=high) of Zambia in 2009 to that in 2014?
Ensure brevity in your answer.  1.06. What is the ratio of the Rating (1=low 6=high) in Sub-Saharan Africa (developing only) in 2010 to that in 2011?
Make the answer very short. 0.98. What is the ratio of the Rating (1=low 6=high) in Gambia, The in 2010 to that in 2011?
Give a very brief answer. 0.97. What is the ratio of the Rating (1=low 6=high) in Zambia in 2010 to that in 2011?
Make the answer very short. 1.03. What is the ratio of the Rating (1=low 6=high) in Sub-Saharan Africa (developing only) in 2010 to that in 2012?
Provide a short and direct response. 0.99. What is the ratio of the Rating (1=low 6=high) of Gambia, The in 2010 to that in 2012?
Your response must be concise. 1. What is the ratio of the Rating (1=low 6=high) of Papua New Guinea in 2010 to that in 2012?
Provide a short and direct response. 1.04. What is the ratio of the Rating (1=low 6=high) of Zambia in 2010 to that in 2012?
Provide a succinct answer. 1.06. What is the ratio of the Rating (1=low 6=high) in Sub-Saharan Africa (developing only) in 2010 to that in 2013?
Your answer should be very brief. 0.99. What is the ratio of the Rating (1=low 6=high) in Zambia in 2010 to that in 2013?
Provide a succinct answer. 1.06. What is the ratio of the Rating (1=low 6=high) in Papua New Guinea in 2010 to that in 2014?
Your response must be concise. 1.08. What is the ratio of the Rating (1=low 6=high) in Zambia in 2010 to that in 2014?
Ensure brevity in your answer.  1.06. What is the ratio of the Rating (1=low 6=high) of Sub-Saharan Africa (developing only) in 2011 to that in 2012?
Ensure brevity in your answer.  1.01. What is the ratio of the Rating (1=low 6=high) of Gambia, The in 2011 to that in 2012?
Offer a very short reply. 1.03. What is the ratio of the Rating (1=low 6=high) in Zambia in 2011 to that in 2012?
Your answer should be compact. 1.03. What is the ratio of the Rating (1=low 6=high) of Gambia, The in 2011 to that in 2013?
Your answer should be very brief. 1.03. What is the ratio of the Rating (1=low 6=high) of Papua New Guinea in 2011 to that in 2013?
Ensure brevity in your answer.  1.04. What is the ratio of the Rating (1=low 6=high) of Zambia in 2011 to that in 2013?
Give a very brief answer. 1.03. What is the ratio of the Rating (1=low 6=high) of Gambia, The in 2011 to that in 2014?
Make the answer very short. 1.03. What is the ratio of the Rating (1=low 6=high) of Zambia in 2011 to that in 2014?
Make the answer very short. 1.03. What is the ratio of the Rating (1=low 6=high) of Zambia in 2012 to that in 2013?
Provide a succinct answer. 1. What is the ratio of the Rating (1=low 6=high) of Sub-Saharan Africa (developing only) in 2012 to that in 2014?
Keep it short and to the point. 0.99. What is the ratio of the Rating (1=low 6=high) in Gambia, The in 2012 to that in 2014?
Keep it short and to the point. 1. What is the ratio of the Rating (1=low 6=high) of Papua New Guinea in 2012 to that in 2014?
Ensure brevity in your answer.  1.04. What is the ratio of the Rating (1=low 6=high) of Zambia in 2012 to that in 2014?
Your response must be concise. 1. What is the difference between the highest and the second highest Rating (1=low 6=high) of Sub-Saharan Africa (developing only)?
Give a very brief answer. 0.01. What is the difference between the highest and the second highest Rating (1=low 6=high) in Gambia, The?
Provide a short and direct response. 0.1. What is the difference between the highest and the second highest Rating (1=low 6=high) of Zambia?
Offer a very short reply. 0. What is the difference between the highest and the lowest Rating (1=low 6=high) in Sub-Saharan Africa (developing only)?
Provide a succinct answer. 0.11. What is the difference between the highest and the lowest Rating (1=low 6=high) of Papua New Guinea?
Your answer should be very brief. 0.2. 